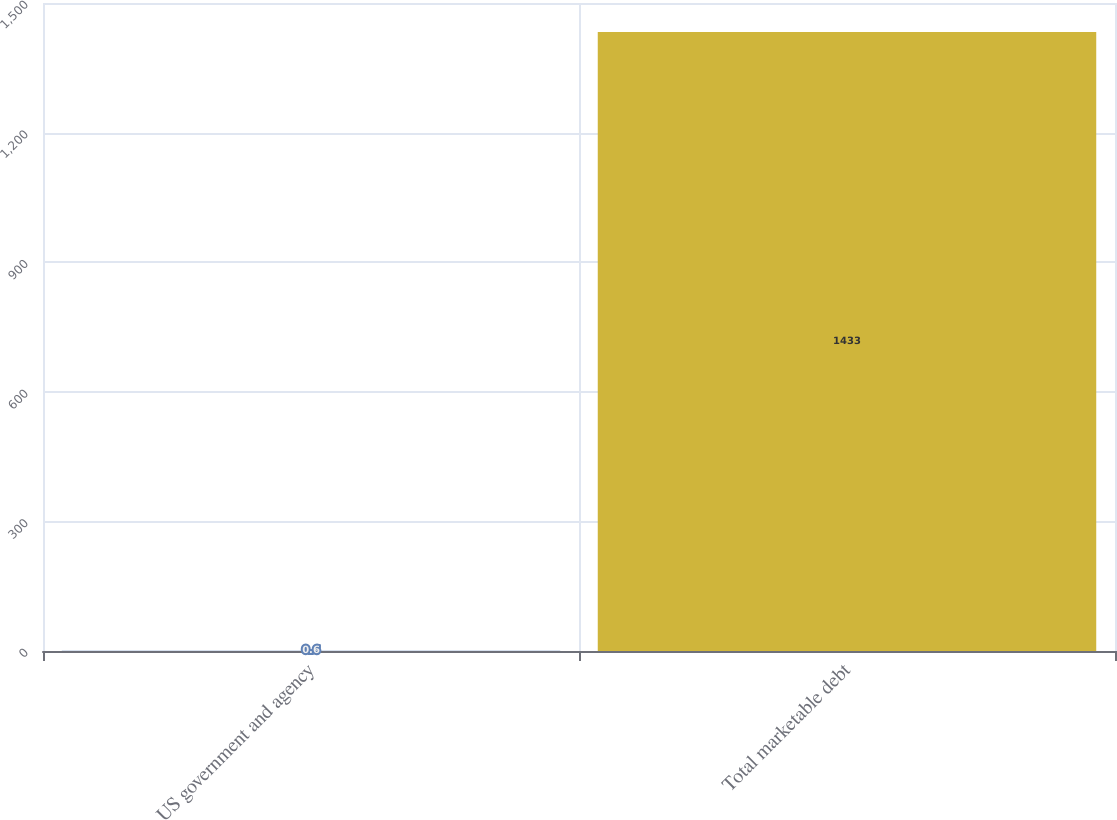Convert chart to OTSL. <chart><loc_0><loc_0><loc_500><loc_500><bar_chart><fcel>US government and agency<fcel>Total marketable debt<nl><fcel>0.6<fcel>1433<nl></chart> 